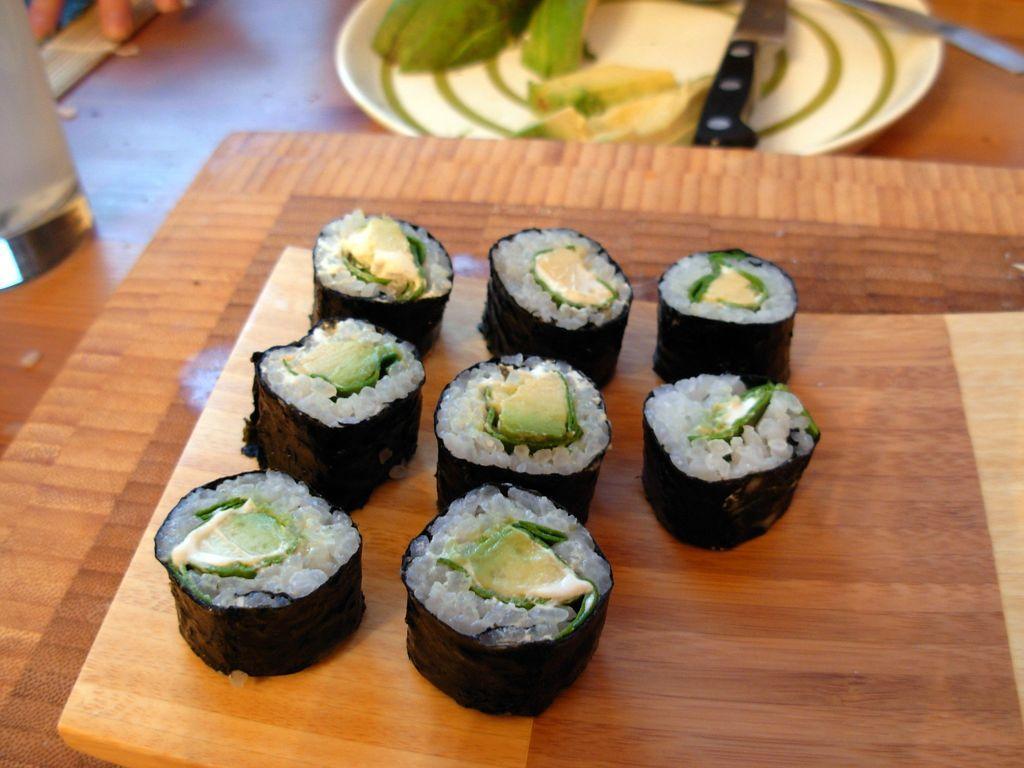Describe this image in one or two sentences. Here we can see food items on a platform on a table and we can also see glass on the left side,food items and knives on a plate and other objects on a table. 